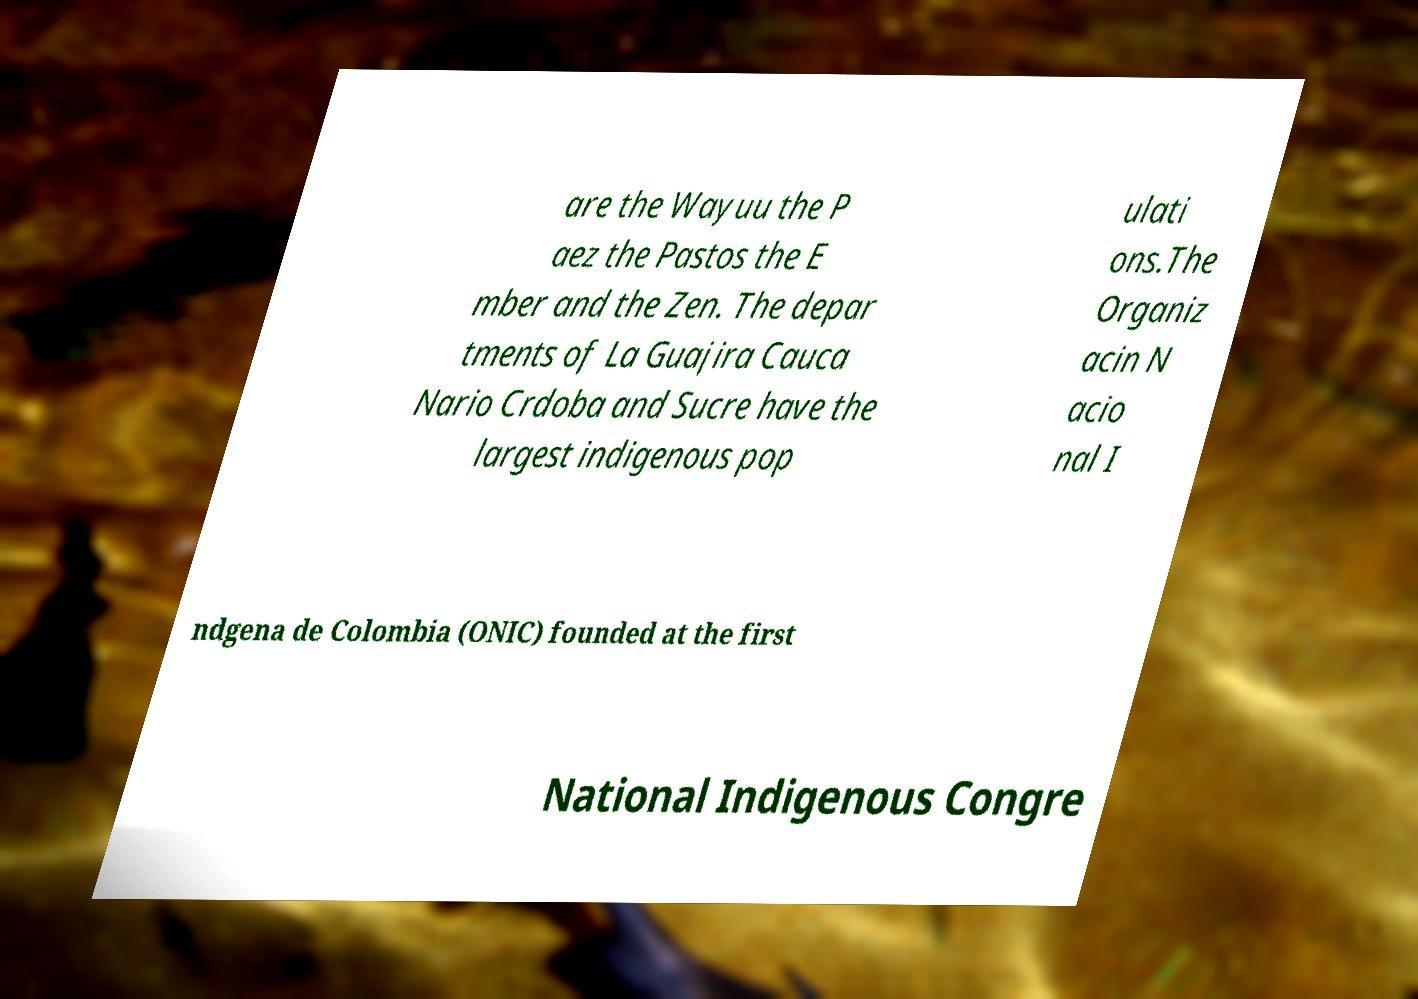There's text embedded in this image that I need extracted. Can you transcribe it verbatim? are the Wayuu the P aez the Pastos the E mber and the Zen. The depar tments of La Guajira Cauca Nario Crdoba and Sucre have the largest indigenous pop ulati ons.The Organiz acin N acio nal I ndgena de Colombia (ONIC) founded at the first National Indigenous Congre 